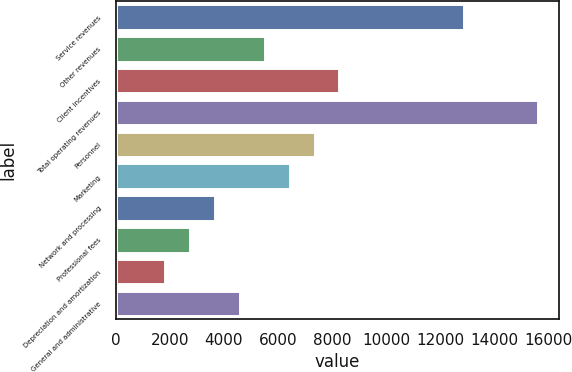<chart> <loc_0><loc_0><loc_500><loc_500><bar_chart><fcel>Service revenues<fcel>Other revenues<fcel>Client incentives<fcel>Total operating revenues<fcel>Personnel<fcel>Marketing<fcel>Network and processing<fcel>Professional fees<fcel>Depreciation and amortization<fcel>General and administrative<nl><fcel>12860.4<fcel>5515.6<fcel>8269.9<fcel>15614.7<fcel>7351.8<fcel>6433.7<fcel>3679.4<fcel>2761.3<fcel>1843.2<fcel>4597.5<nl></chart> 